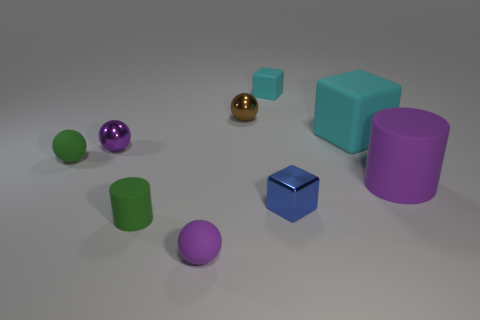What materials are the objects in the image made of? The materials are not specified, but the objects appear to be rendered with different finishes; some have a matte surface, like the tiny green and the purple cubes, while others, such as the small brown ball, appear to have a shiny, reflective surface, suggesting they could be made from materials such as plastic or metal with different coatings. 